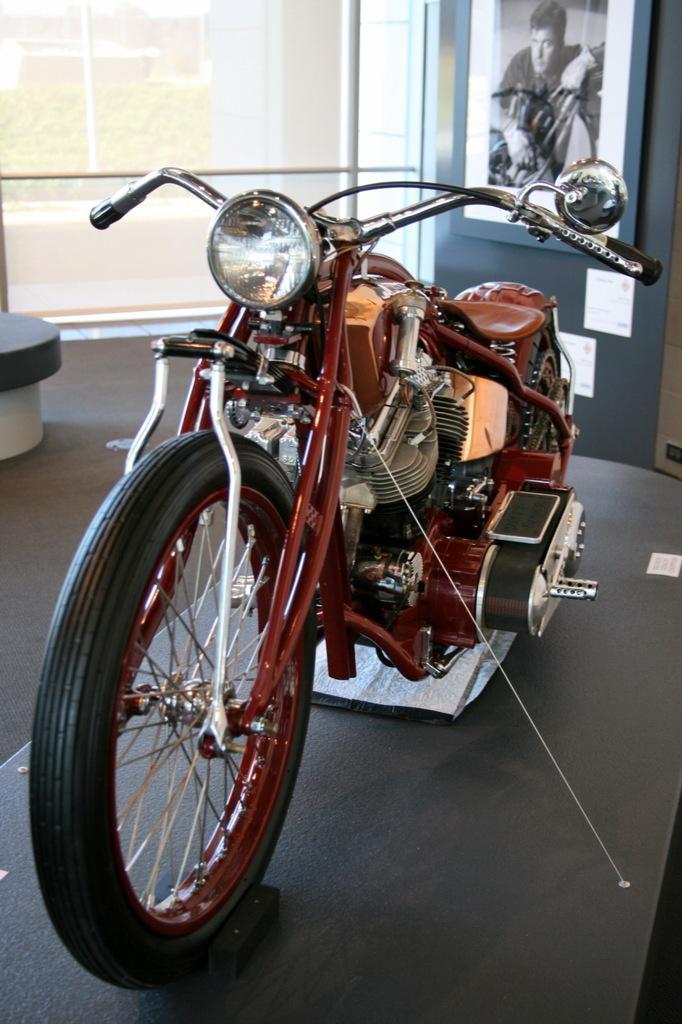Could you give a brief overview of what you see in this image? In this image there is a bike, in the background there is a glass wall and there is a poster. 